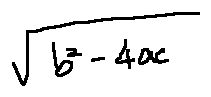Convert formula to latex. <formula><loc_0><loc_0><loc_500><loc_500>\sqrt { b ^ { 2 } - 4 a c }</formula> 